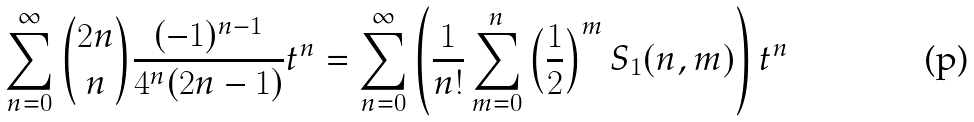Convert formula to latex. <formula><loc_0><loc_0><loc_500><loc_500>\sum _ { n = 0 } ^ { \infty } { 2 n \choose n } \frac { ( - 1 ) ^ { n - 1 } } { 4 ^ { n } ( 2 n - 1 ) } t ^ { n } = \sum _ { n = 0 } ^ { \infty } \left ( \frac { 1 } { n ! } \sum _ { m = 0 } ^ { n } \left ( \frac { 1 } { 2 } \right ) ^ { m } S _ { 1 } ( n , m ) \right ) t ^ { n }</formula> 